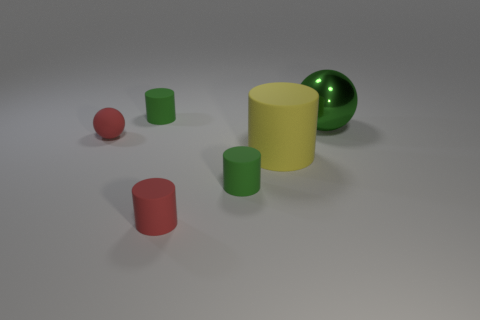Add 3 yellow matte cylinders. How many objects exist? 9 Subtract all large rubber cylinders. How many cylinders are left? 3 Subtract 2 balls. How many balls are left? 0 Subtract all green balls. How many balls are left? 1 Subtract all spheres. How many objects are left? 4 Subtract all yellow matte cylinders. Subtract all spheres. How many objects are left? 3 Add 1 large things. How many large things are left? 3 Add 3 tiny red things. How many tiny red things exist? 5 Subtract 0 purple spheres. How many objects are left? 6 Subtract all blue cylinders. Subtract all blue blocks. How many cylinders are left? 4 